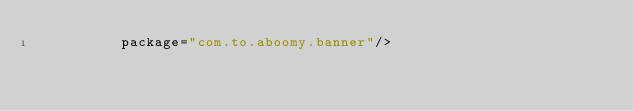Convert code to text. <code><loc_0><loc_0><loc_500><loc_500><_XML_>          package="com.to.aboomy.banner"/>
</code> 